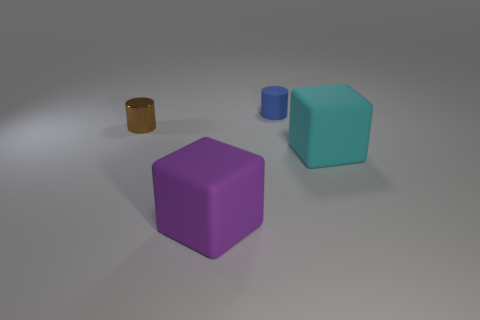Is the shape of the cyan thing the same as the small thing to the left of the purple cube?
Give a very brief answer. No. What number of other things are the same shape as the tiny brown shiny object?
Keep it short and to the point. 1. How many things are purple rubber objects or small things?
Provide a succinct answer. 3. Do the tiny rubber object and the shiny object have the same color?
Keep it short and to the point. No. Are there any other things that have the same size as the blue cylinder?
Offer a terse response. Yes. What shape is the cyan object that is in front of the tiny object behind the brown object?
Offer a very short reply. Cube. Are there fewer blue rubber cylinders than small gray shiny blocks?
Offer a terse response. No. There is a object that is behind the cyan matte thing and on the right side of the metallic cylinder; what is its size?
Your response must be concise. Small. Do the blue object and the cyan object have the same size?
Offer a very short reply. No. There is a matte object in front of the cyan thing; is its color the same as the rubber cylinder?
Give a very brief answer. No. 